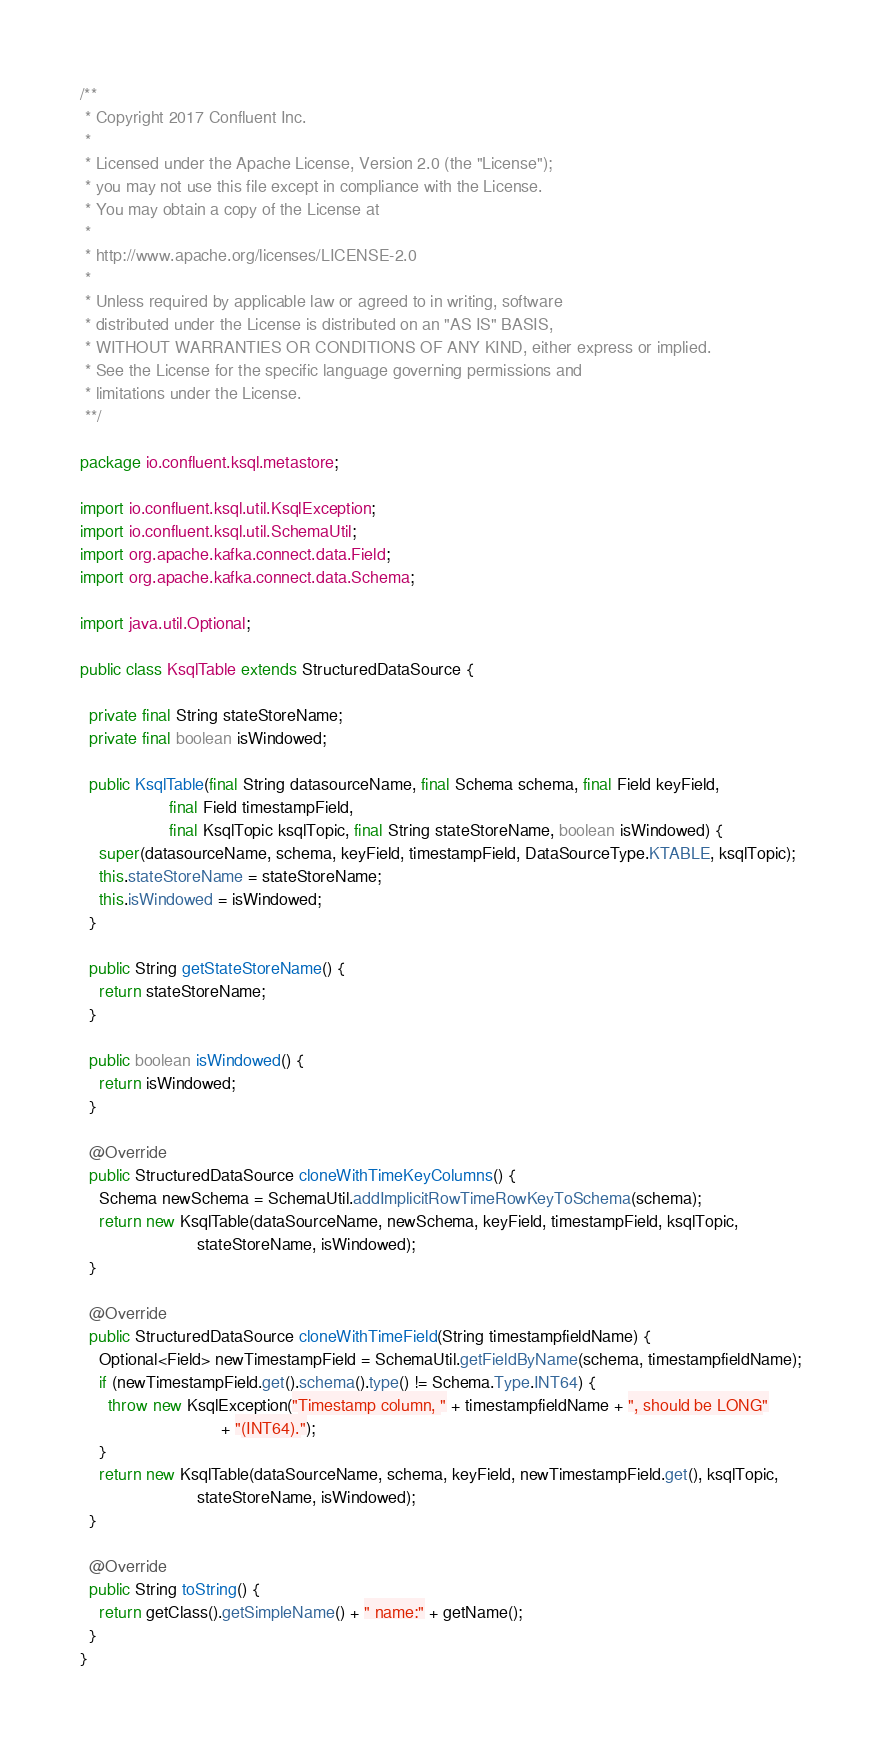Convert code to text. <code><loc_0><loc_0><loc_500><loc_500><_Java_>/**
 * Copyright 2017 Confluent Inc.
 *
 * Licensed under the Apache License, Version 2.0 (the "License");
 * you may not use this file except in compliance with the License.
 * You may obtain a copy of the License at
 *
 * http://www.apache.org/licenses/LICENSE-2.0
 *
 * Unless required by applicable law or agreed to in writing, software
 * distributed under the License is distributed on an "AS IS" BASIS,
 * WITHOUT WARRANTIES OR CONDITIONS OF ANY KIND, either express or implied.
 * See the License for the specific language governing permissions and
 * limitations under the License.
 **/

package io.confluent.ksql.metastore;

import io.confluent.ksql.util.KsqlException;
import io.confluent.ksql.util.SchemaUtil;
import org.apache.kafka.connect.data.Field;
import org.apache.kafka.connect.data.Schema;

import java.util.Optional;

public class KsqlTable extends StructuredDataSource {

  private final String stateStoreName;
  private final boolean isWindowed;

  public KsqlTable(final String datasourceName, final Schema schema, final Field keyField,
                   final Field timestampField,
                   final KsqlTopic ksqlTopic, final String stateStoreName, boolean isWindowed) {
    super(datasourceName, schema, keyField, timestampField, DataSourceType.KTABLE, ksqlTopic);
    this.stateStoreName = stateStoreName;
    this.isWindowed = isWindowed;
  }

  public String getStateStoreName() {
    return stateStoreName;
  }

  public boolean isWindowed() {
    return isWindowed;
  }

  @Override
  public StructuredDataSource cloneWithTimeKeyColumns() {
    Schema newSchema = SchemaUtil.addImplicitRowTimeRowKeyToSchema(schema);
    return new KsqlTable(dataSourceName, newSchema, keyField, timestampField, ksqlTopic,
                         stateStoreName, isWindowed);
  }

  @Override
  public StructuredDataSource cloneWithTimeField(String timestampfieldName) {
    Optional<Field> newTimestampField = SchemaUtil.getFieldByName(schema, timestampfieldName);
    if (newTimestampField.get().schema().type() != Schema.Type.INT64) {
      throw new KsqlException("Timestamp column, " + timestampfieldName + ", should be LONG"
                              + "(INT64).");
    }
    return new KsqlTable(dataSourceName, schema, keyField, newTimestampField.get(), ksqlTopic,
                         stateStoreName, isWindowed);
  }

  @Override
  public String toString() {
    return getClass().getSimpleName() + " name:" + getName();
  }
}
</code> 